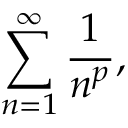<formula> <loc_0><loc_0><loc_500><loc_500>\sum _ { n = 1 } ^ { \infty } { \frac { 1 } { n ^ { p } } } ,</formula> 